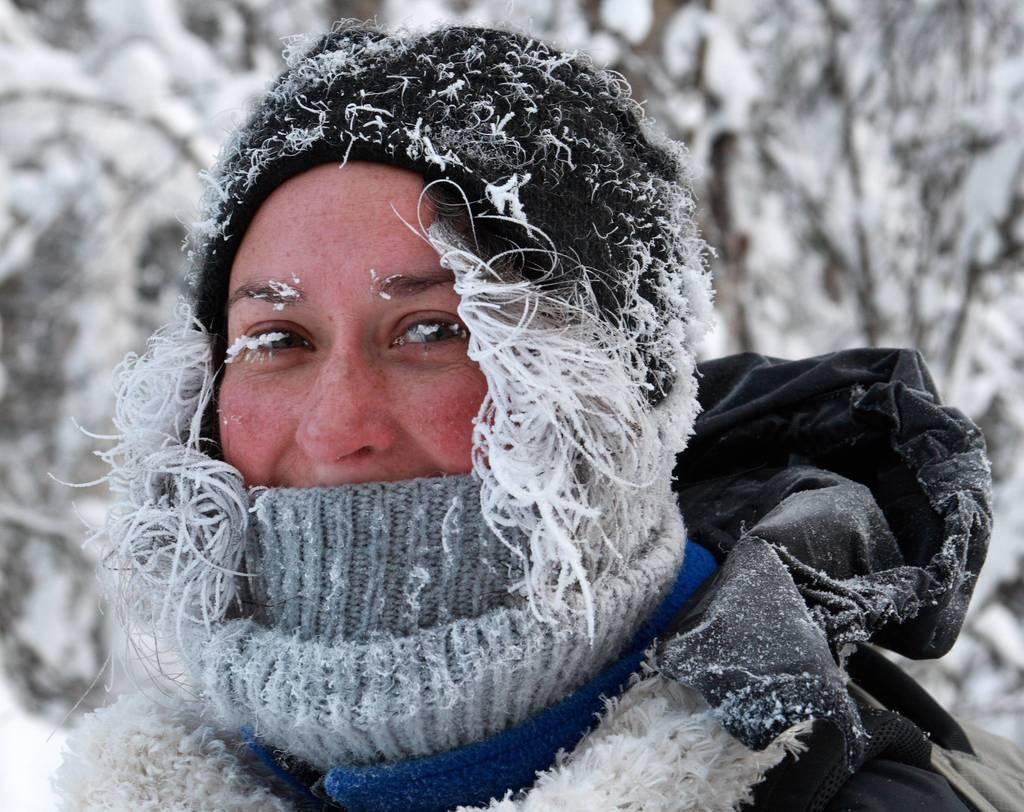Who is present in the image? There is a woman in the image. What is the woman wearing? The woman is wearing clothes and a cap. What is the weather like in the image? There is snow visible in the image, indicating a cold or wintry environment. How would you describe the background of the image? The background of the image is blurred. What type of beef can be seen in the image? There is no beef present in the image. How many clovers are visible in the image? There are no clovers visible in the image. 